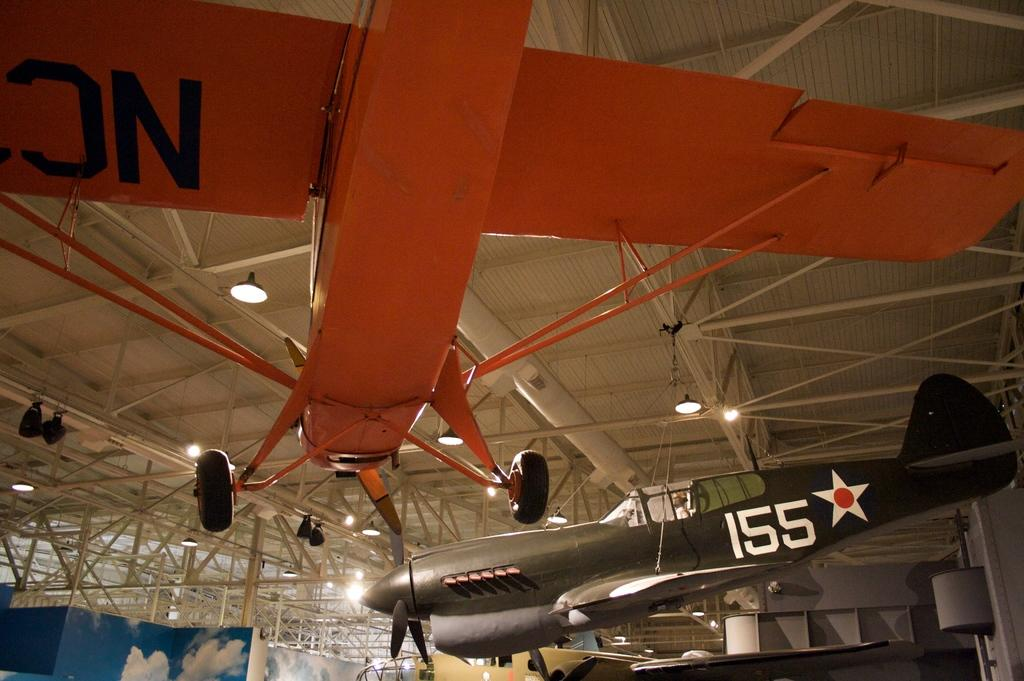<image>
Offer a succinct explanation of the picture presented. One of the planes on display bears the numbers 155 to the left of a white star with a circle in the middle. 